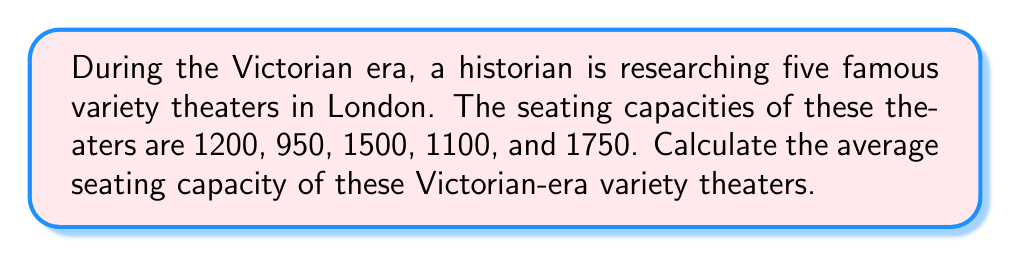Show me your answer to this math problem. To calculate the average seating capacity, we need to follow these steps:

1. Sum up the seating capacities of all theaters:
   $$1200 + 950 + 1500 + 1100 + 1750 = 6500$$

2. Count the total number of theaters:
   There are 5 theaters in total.

3. Calculate the average by dividing the sum by the number of theaters:
   $$\text{Average} = \frac{\text{Sum of capacities}}{\text{Number of theaters}}$$
   $$\text{Average} = \frac{6500}{5} = 1300$$

Therefore, the average seating capacity of these Victorian-era variety theaters is 1300 seats.
Answer: 1300 seats 